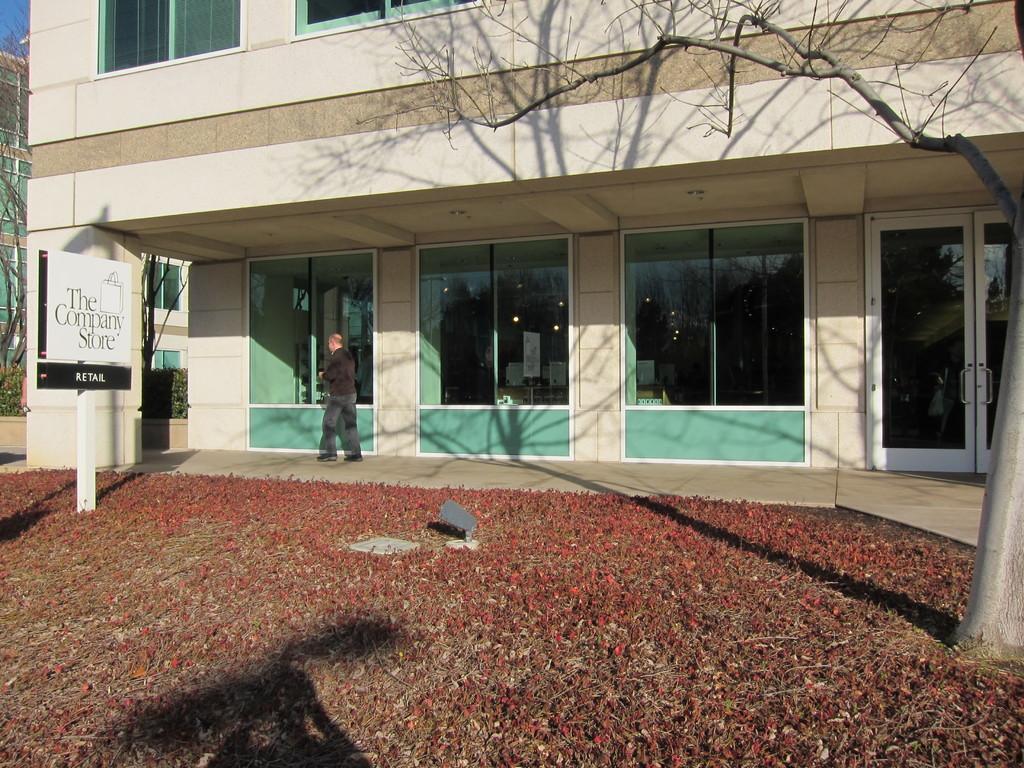In one or two sentences, can you explain what this image depicts? In this picture we can see buildings with windows and doors. In front of the building, a person is standing and there is an object on the ground. On the left side of the image, there is a pole with a board. On the left and right side of the image, there are trees. In the top left corner of the image, there is the sky. Inside the building, there are lights and some objects. 